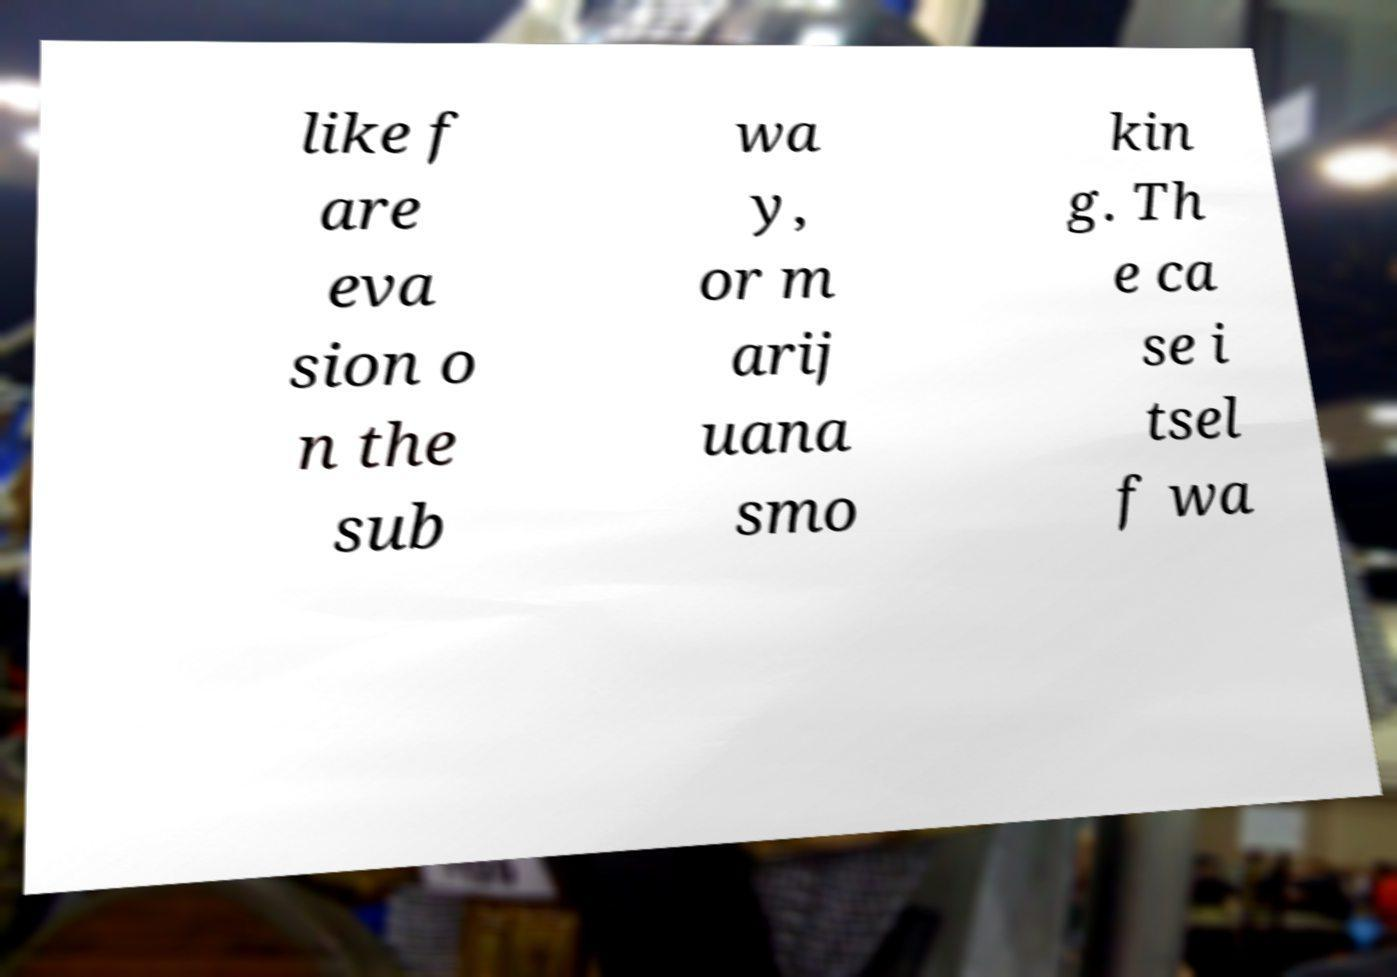Please read and relay the text visible in this image. What does it say? like f are eva sion o n the sub wa y, or m arij uana smo kin g. Th e ca se i tsel f wa 